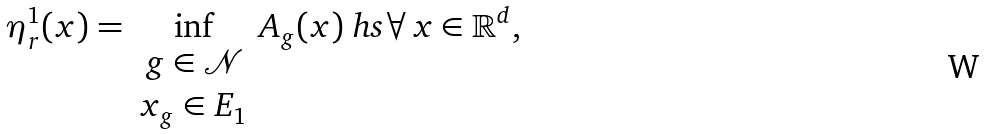<formula> <loc_0><loc_0><loc_500><loc_500>\eta _ { r } ^ { 1 } ( x ) = \inf _ { \begin{array} { c } g \in \mathcal { N } \\ x _ { g } \in E _ { 1 } \end{array} } A _ { g } ( x ) \ h s \forall \, x \in \mathbb { R } ^ { d } ,</formula> 